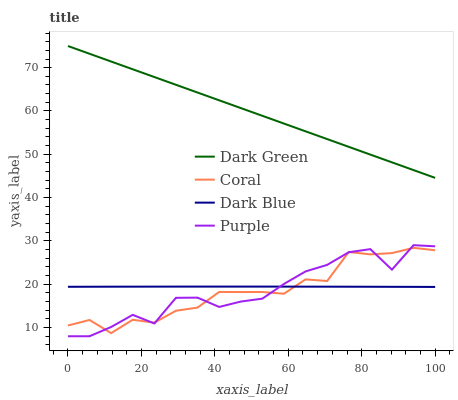Does Dark Blue have the minimum area under the curve?
Answer yes or no. No. Does Dark Blue have the maximum area under the curve?
Answer yes or no. No. Is Dark Blue the smoothest?
Answer yes or no. No. Is Dark Blue the roughest?
Answer yes or no. No. Does Dark Blue have the lowest value?
Answer yes or no. No. Does Coral have the highest value?
Answer yes or no. No. Is Coral less than Dark Green?
Answer yes or no. Yes. Is Dark Green greater than Dark Blue?
Answer yes or no. Yes. Does Coral intersect Dark Green?
Answer yes or no. No. 